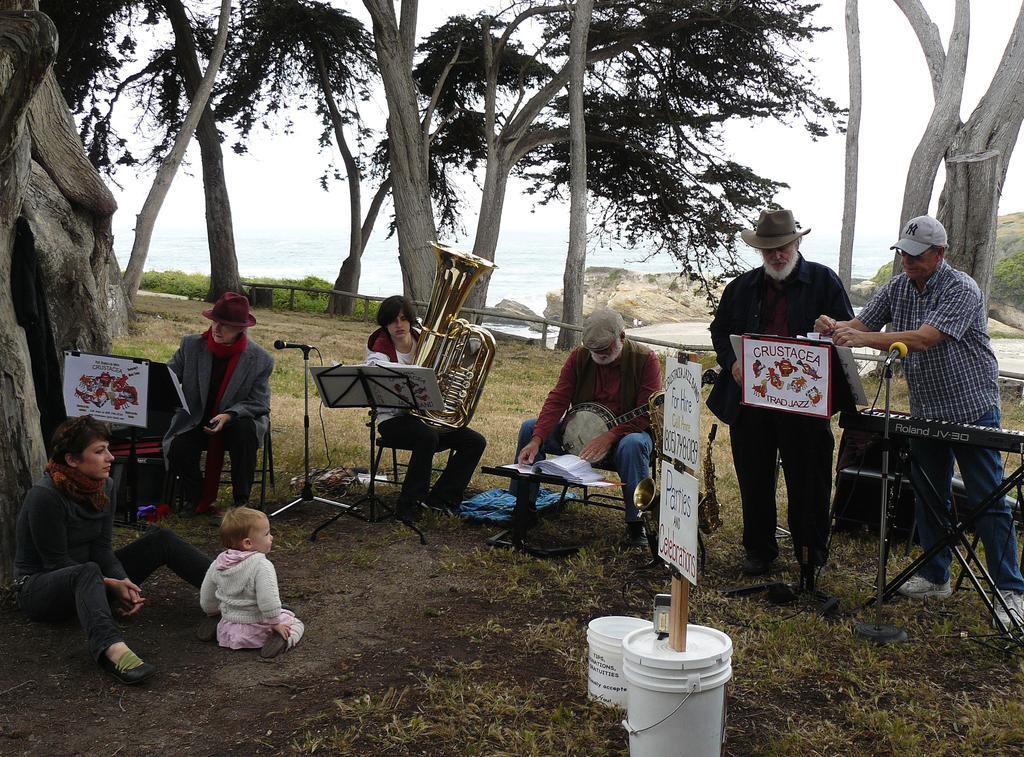In one or two sentences, can you explain what this image depicts? In this image few persons are sitting on the chairs. There are few strands, having books. There are few mike stands on the grassland. Right side there is a person wearing a cap. He is standing. Before him there is a piano. Beside him there is a person wearing a cap. Left side there is a baby and a person are sitting on the grassland having few buckets. In the bucket there is a wooden plank having few boards attached to it. There are few trees on the grassland having few plants. Right side there are few rocks. Background there is water. Top of the image there is sky. 